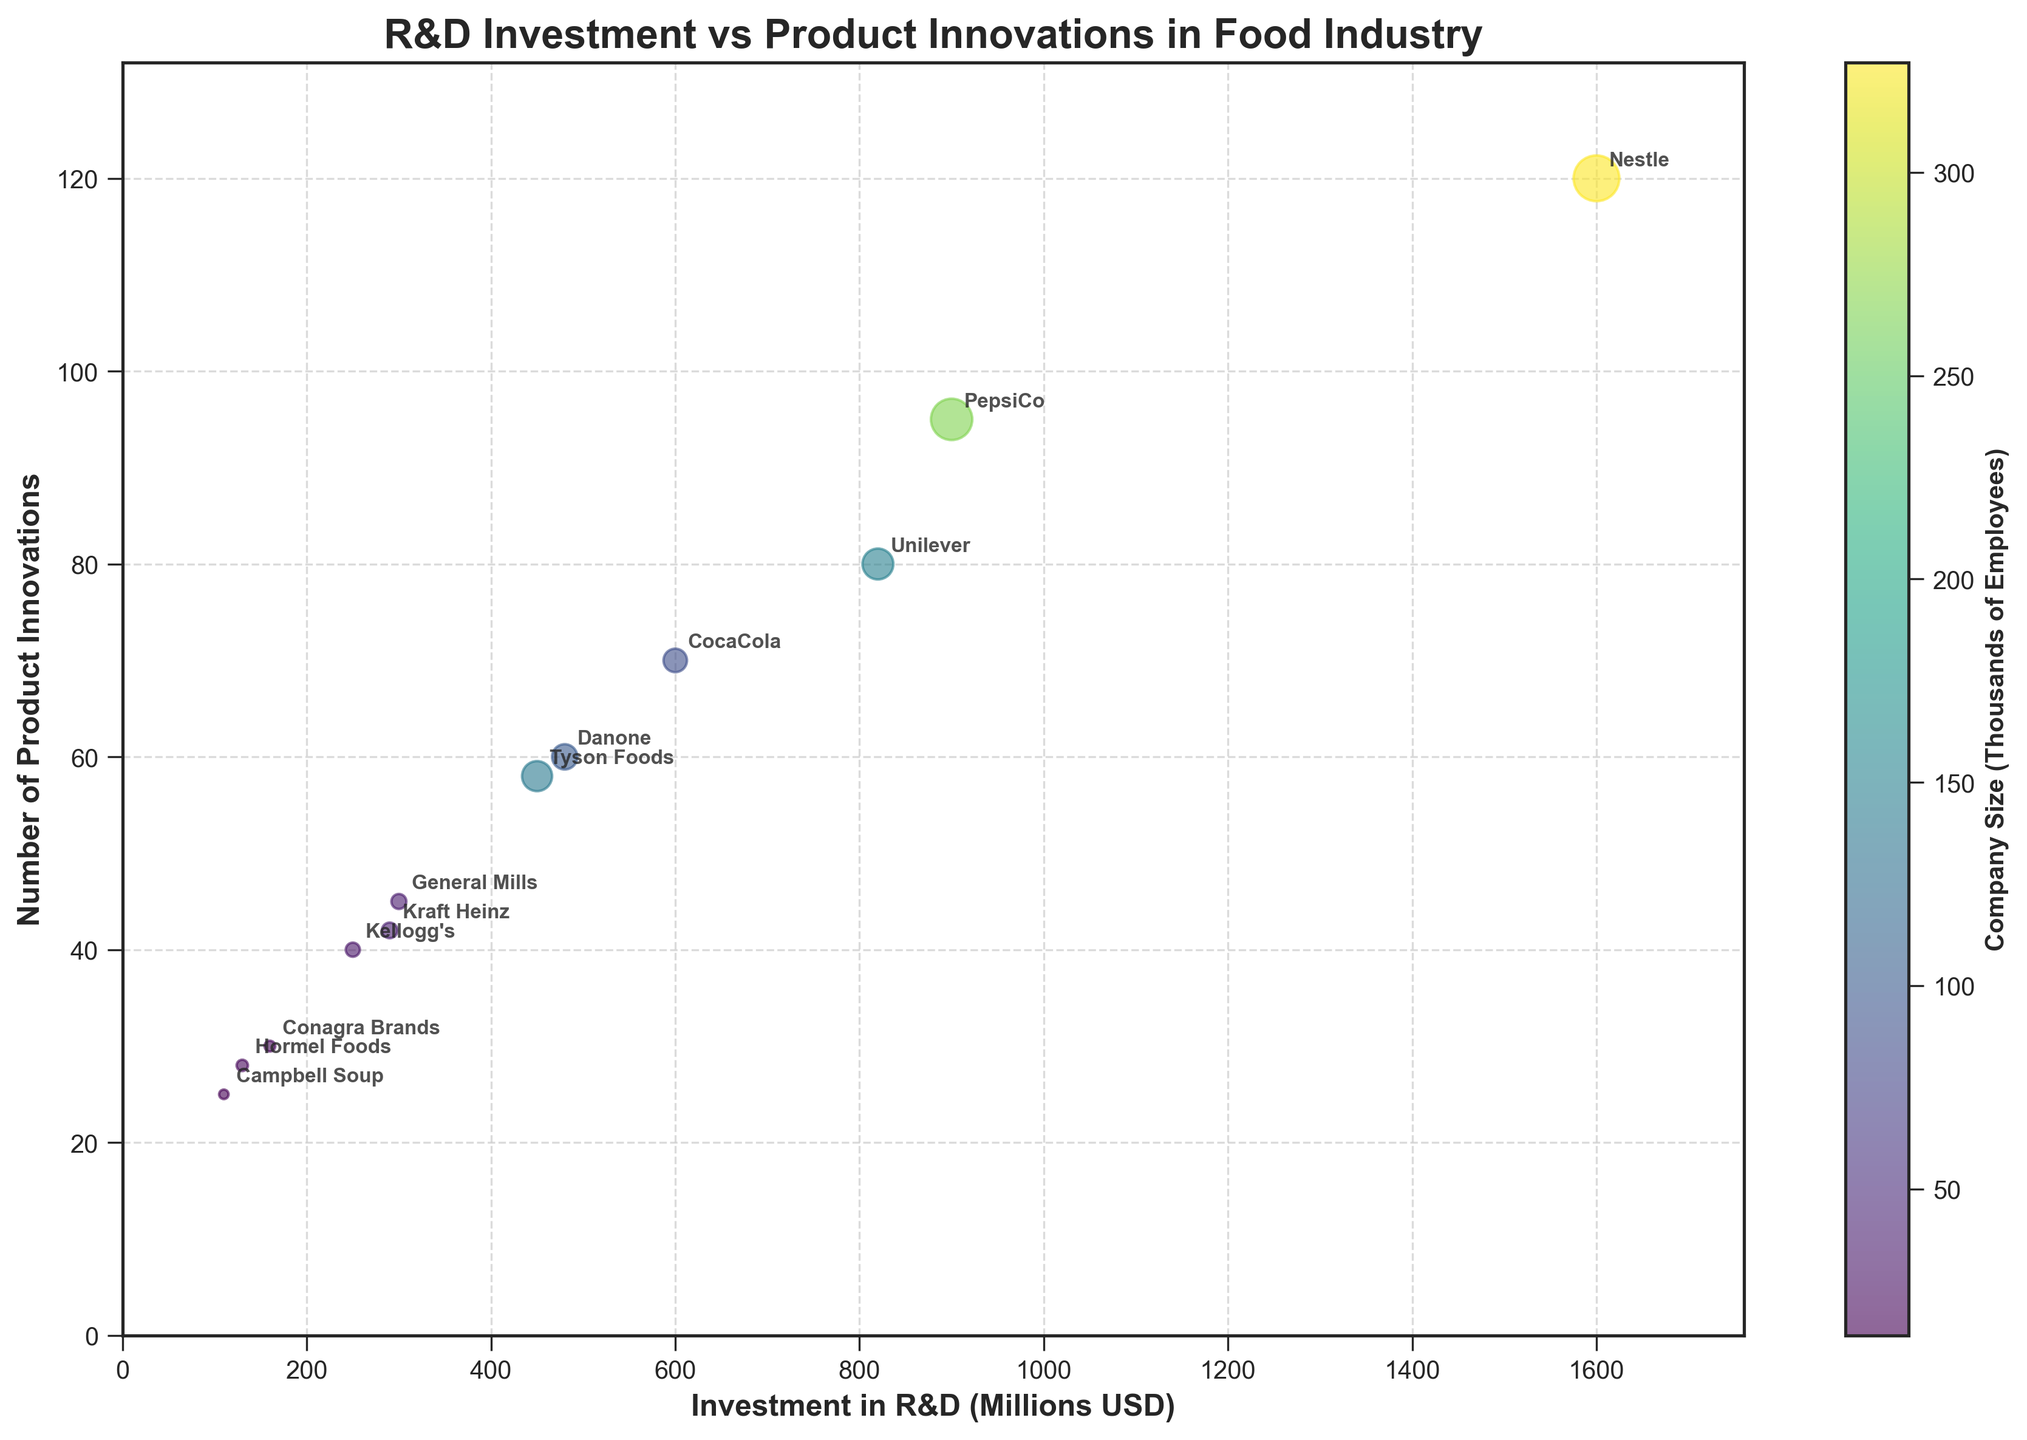What is the title of the chart? The title of the chart is usually located at the top and describes the main subject of the plot. In this case, it should say "R&D Investment vs Product Innovations in Food Industry".
Answer: R&D Investment vs Product Innovations in Food Industry How many companies are represented in the chart? By looking at the number of labeled data points (bubbles) in the chart, we can count and identify that there are 12 companies.
Answer: 12 Which company has the highest investment in R&D? Find the bubble that is furthest to the right on the x-axis, as R&D investment is plotted on the x-axis. The furthest right bubble represents Nestle.
Answer: Nestle What is the range of company sizes in the chart? Identify the smallest and largest bubble sizes, which represent the smallest and largest company sizes, respectively. Hormel Foods has the smallest bubble size (14,000 employees) and Nestle the largest (327,000 employees).
Answer: 14,000 to 327,000 employees Which company has the highest number of product innovations? Locate the bubble that is highest on the y-axis, as the number of product innovations is plotted on the y-axis. The highest bubble corresponds to Nestle with 120 product innovations.
Answer: Nestle How does the number of product innovations compare between Unilever and CocaCola? Find the bubbles for Unilever and CocaCola and compare their positions on the y-axis. Unilever has 80 innovations and CocaCola has 70.
Answer: Unilever has 10 more innovations than CocaCola What is the average number of product innovations for companies with more than 100,000 employees? Identify companies with more than 100,000 employees (Nestle, PepsiCo, Danone), then calculate the average. The values are 120 (Nestle), 95 (PepsiCo), and 60 (Danone), yielding (120 + 95 + 60) / 3 = 91.7.
Answer: 91.7 Does a larger company size generally correlate with higher R&D investment? Observe the trend of bubble sizes (company size) relative to their position on the x-axis (R&D investment). Generally, larger bubbles are positioned further right, indicating a positive correlation.
Answer: Yes Which companies have both higher than 500 million USD investment in R&D and more than 50 product innovations? Identify bubbles beyond 500 on the x-axis and above 50 on the y-axis. Companies meeting both criteria are Nestle, PepsiCo, CocaCola, and Unilever.
Answer: Nestle, PepsiCo, CocaCola, Unilever Is there any company with less than 200 million USD in R&D investment but more than 30 product innovations? Locate bubbles below 200 on the x-axis and above 30 on the y-axis. Conagra Brands fits this description.
Answer: Conagra Brands 